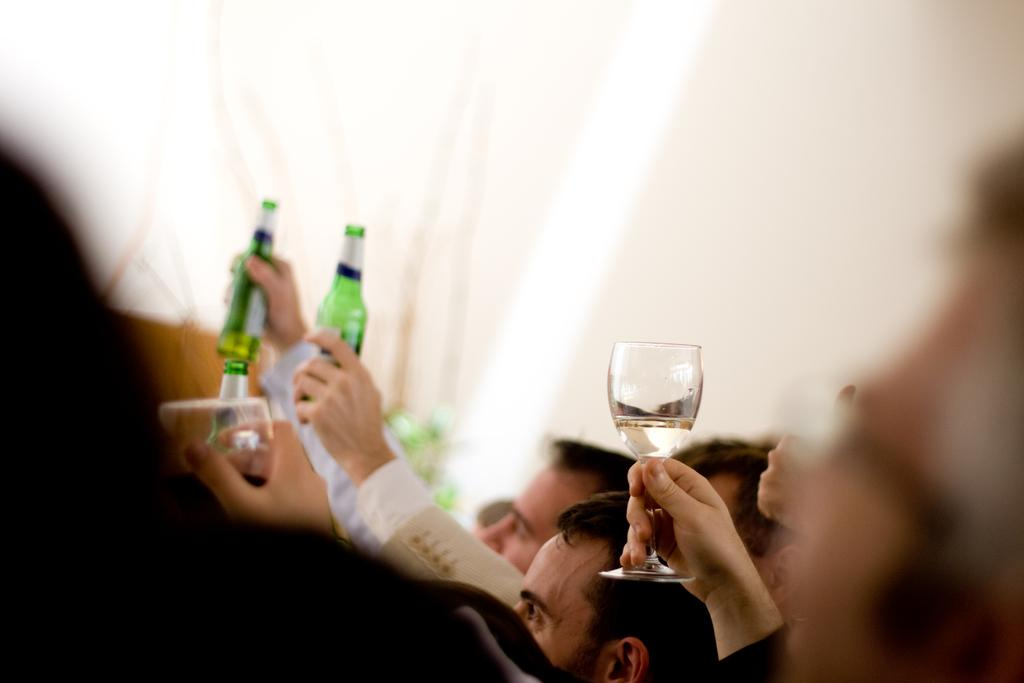What is the main subject of the image? The main subject of the image is a group of people. What are some people in the group holding in the image? Some people in the group are holding wine glasses, while others are holding bottles. What type of mint can be seen growing in the image? There is no mint plant present in the image. Can you tell me how many toads are visible in the image? There are no toads visible in the image. What tool is being used by someone in the image to fix a machine? There is no tool, such as a wrench, being used by anyone in the image. 